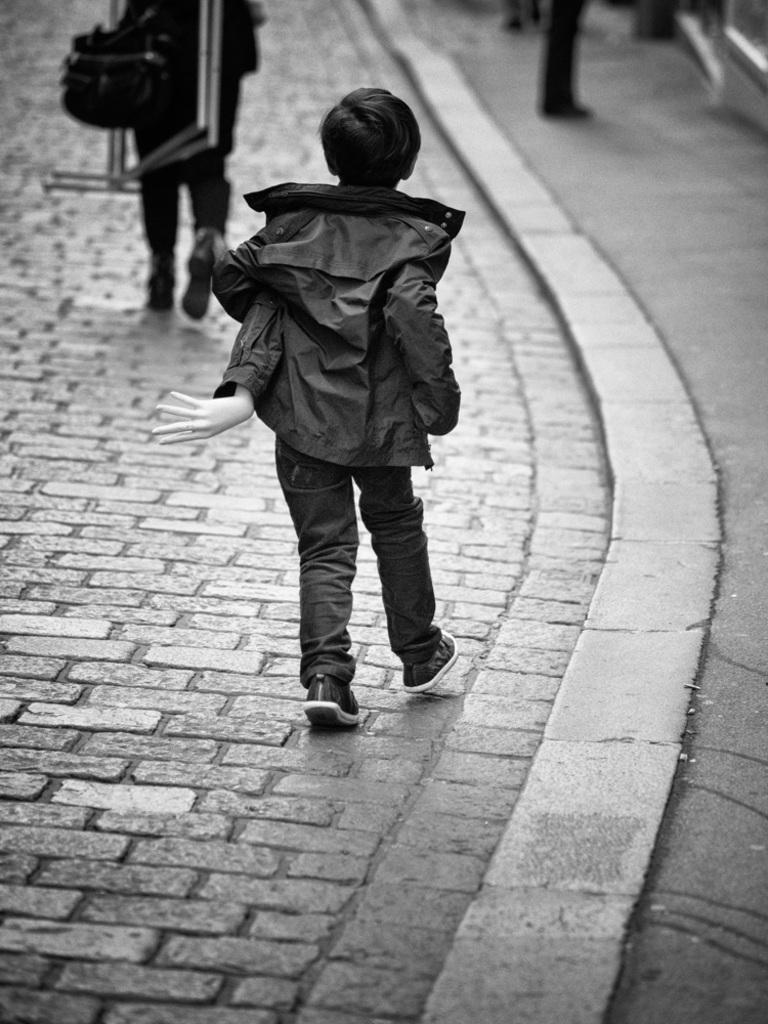Please provide a concise description of this image. Black and white picture. Here we can see a boy. This boy wore a jacket. Background it is blur. We can see people. This person is holding objects. 